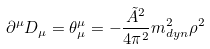Convert formula to latex. <formula><loc_0><loc_0><loc_500><loc_500>\partial ^ { \mu } D _ { \mu } = \theta _ { \mu } ^ { \mu } = - \frac { \tilde { A } ^ { 2 } } { 4 \pi ^ { 2 } } m _ { d y n } ^ { 2 } \rho ^ { 2 }</formula> 